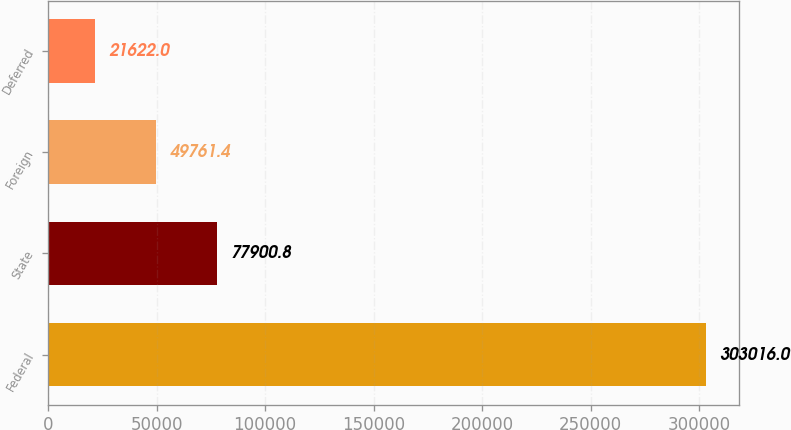Convert chart. <chart><loc_0><loc_0><loc_500><loc_500><bar_chart><fcel>Federal<fcel>State<fcel>Foreign<fcel>Deferred<nl><fcel>303016<fcel>77900.8<fcel>49761.4<fcel>21622<nl></chart> 